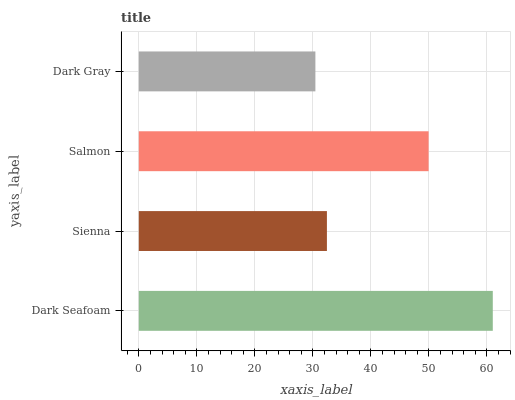Is Dark Gray the minimum?
Answer yes or no. Yes. Is Dark Seafoam the maximum?
Answer yes or no. Yes. Is Sienna the minimum?
Answer yes or no. No. Is Sienna the maximum?
Answer yes or no. No. Is Dark Seafoam greater than Sienna?
Answer yes or no. Yes. Is Sienna less than Dark Seafoam?
Answer yes or no. Yes. Is Sienna greater than Dark Seafoam?
Answer yes or no. No. Is Dark Seafoam less than Sienna?
Answer yes or no. No. Is Salmon the high median?
Answer yes or no. Yes. Is Sienna the low median?
Answer yes or no. Yes. Is Dark Gray the high median?
Answer yes or no. No. Is Salmon the low median?
Answer yes or no. No. 